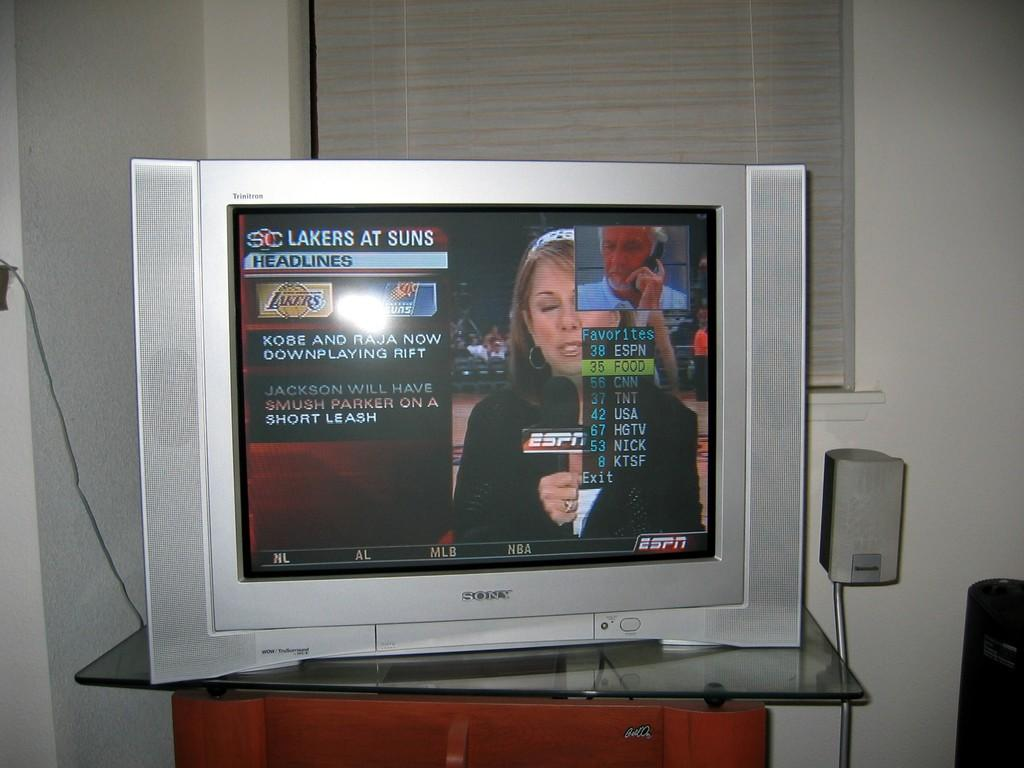Provide a one-sentence caption for the provided image. A television with the words Lakers at Suns on the top left of the screen. 